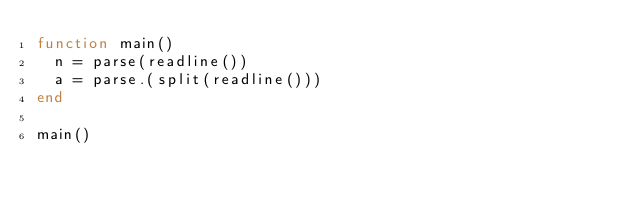<code> <loc_0><loc_0><loc_500><loc_500><_Julia_>function main()
  n = parse(readline())
  a = parse.(split(readline()))
end
    
main()</code> 